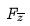<formula> <loc_0><loc_0><loc_500><loc_500>F _ { \overline { z } }</formula> 